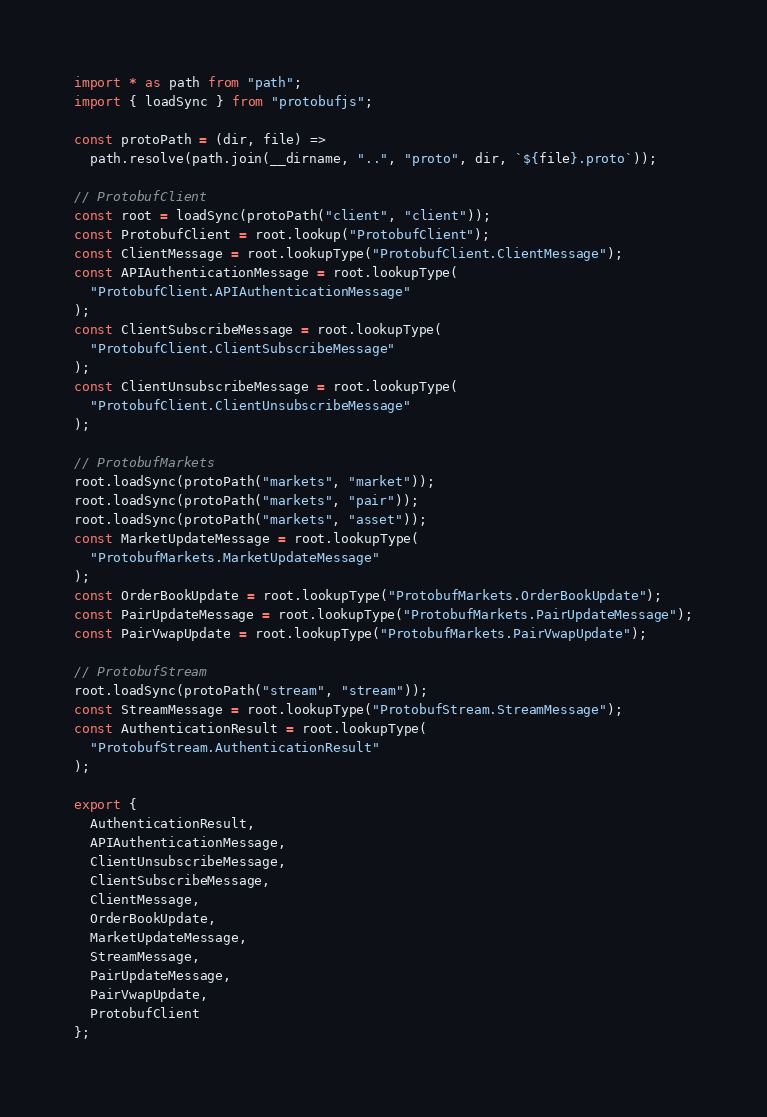Convert code to text. <code><loc_0><loc_0><loc_500><loc_500><_TypeScript_>import * as path from "path";
import { loadSync } from "protobufjs";

const protoPath = (dir, file) =>
  path.resolve(path.join(__dirname, "..", "proto", dir, `${file}.proto`));

// ProtobufClient
const root = loadSync(protoPath("client", "client"));
const ProtobufClient = root.lookup("ProtobufClient");
const ClientMessage = root.lookupType("ProtobufClient.ClientMessage");
const APIAuthenticationMessage = root.lookupType(
  "ProtobufClient.APIAuthenticationMessage"
);
const ClientSubscribeMessage = root.lookupType(
  "ProtobufClient.ClientSubscribeMessage"
);
const ClientUnsubscribeMessage = root.lookupType(
  "ProtobufClient.ClientUnsubscribeMessage"
);

// ProtobufMarkets
root.loadSync(protoPath("markets", "market"));
root.loadSync(protoPath("markets", "pair"));
root.loadSync(protoPath("markets", "asset"));
const MarketUpdateMessage = root.lookupType(
  "ProtobufMarkets.MarketUpdateMessage"
);
const OrderBookUpdate = root.lookupType("ProtobufMarkets.OrderBookUpdate");
const PairUpdateMessage = root.lookupType("ProtobufMarkets.PairUpdateMessage");
const PairVwapUpdate = root.lookupType("ProtobufMarkets.PairVwapUpdate");

// ProtobufStream
root.loadSync(protoPath("stream", "stream"));
const StreamMessage = root.lookupType("ProtobufStream.StreamMessage");
const AuthenticationResult = root.lookupType(
  "ProtobufStream.AuthenticationResult"
);

export {
  AuthenticationResult,
  APIAuthenticationMessage,
  ClientUnsubscribeMessage,
  ClientSubscribeMessage,
  ClientMessage,
  OrderBookUpdate,
  MarketUpdateMessage,
  StreamMessage,
  PairUpdateMessage,
  PairVwapUpdate,
  ProtobufClient
};
</code> 